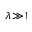<formula> <loc_0><loc_0><loc_500><loc_500>\lambda \, \gg \, 1</formula> 